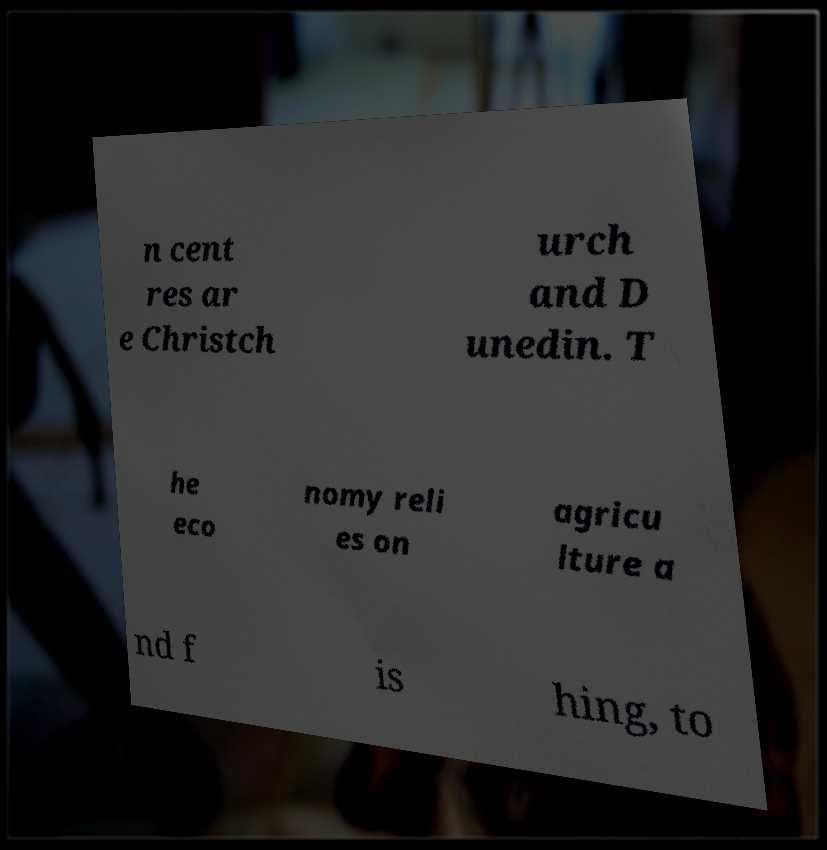Can you read and provide the text displayed in the image?This photo seems to have some interesting text. Can you extract and type it out for me? n cent res ar e Christch urch and D unedin. T he eco nomy reli es on agricu lture a nd f is hing, to 